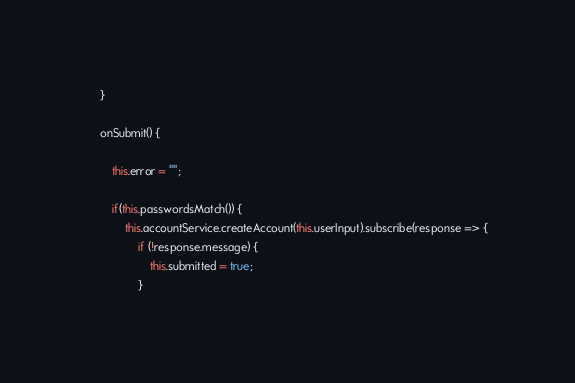Convert code to text. <code><loc_0><loc_0><loc_500><loc_500><_TypeScript_>    }

    onSubmit() {
        
        this.error = "";

        if(this.passwordsMatch()) {
            this.accountService.createAccount(this.userInput).subscribe(response => {
                if (!response.message) {
                    this.submitted = true;
                }</code> 